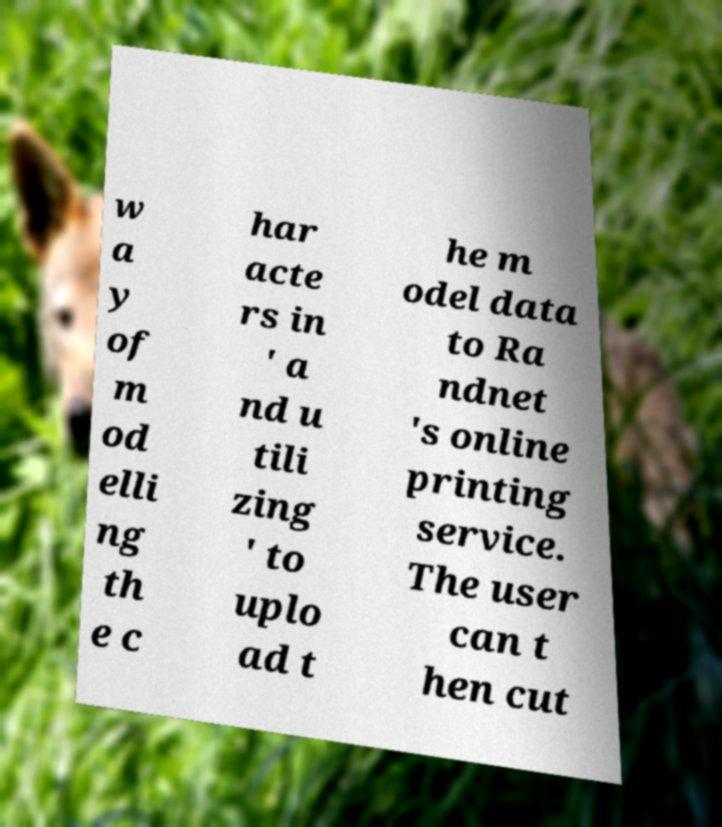Can you read and provide the text displayed in the image?This photo seems to have some interesting text. Can you extract and type it out for me? w a y of m od elli ng th e c har acte rs in ' a nd u tili zing ' to uplo ad t he m odel data to Ra ndnet 's online printing service. The user can t hen cut 